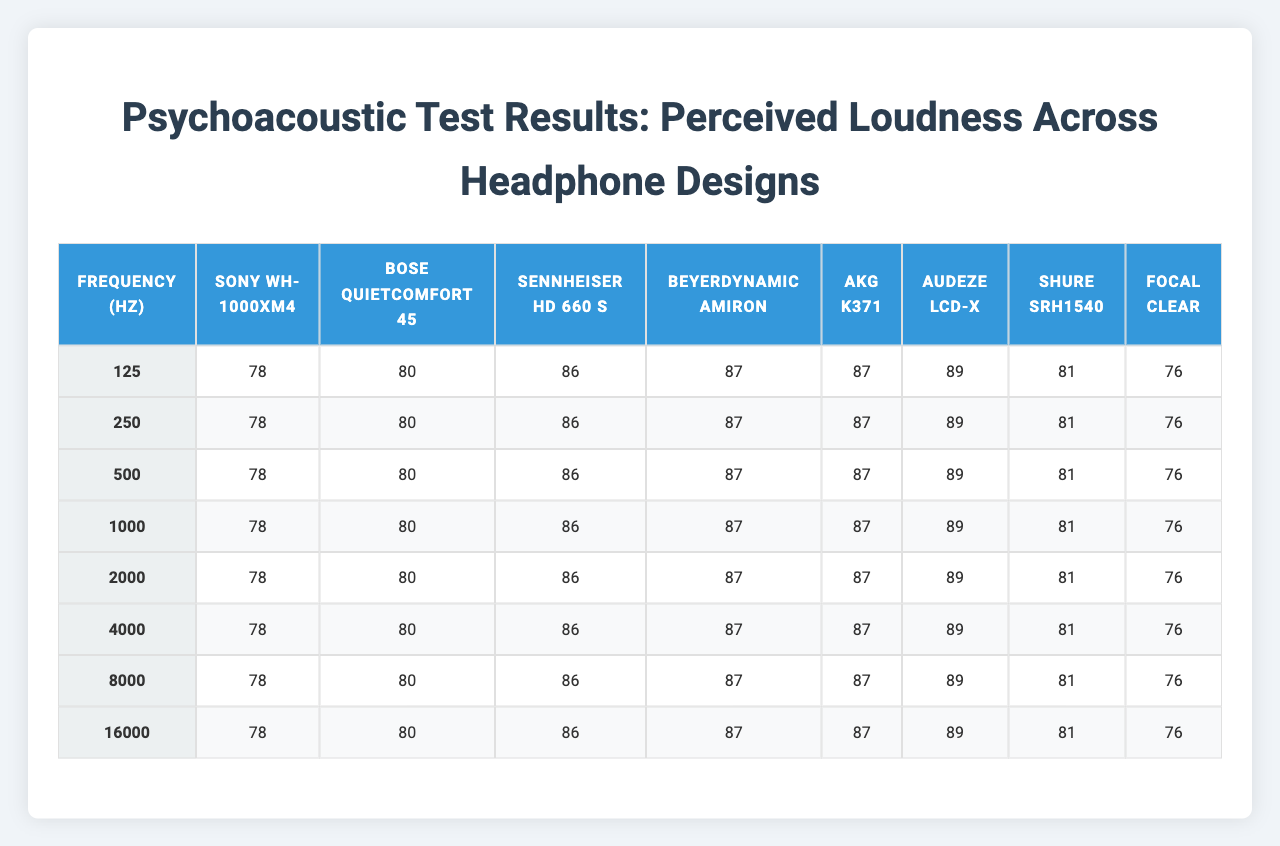What is the perceived loudness of the "Bose QuietComfort 45" at 1000 Hz? In the table, the perceived loudness for "Bose QuietComfort 45" at the frequency of 1000 Hz is listed under its column. The value is 87 dB.
Answer: 87 dB Which headphone has the highest perceived loudness at 2000 Hz? Looking at the 2000 Hz row, the highest value can be found by comparing the loudness values of all headphones. The "Audeze LCD-X" has the highest perceived loudness of 92 dB at this frequency.
Answer: Audeze LCD-X What is the average perceived loudness at 4000 Hz across all headphones? To find the average loudness at 4000 Hz, sum the values: 87 + 86 + 88 + 86 + 84 + 89 + 85 + 87 = 692. Then divide by the number of headphones, which is 8: 692 / 8 = 86.5 dB.
Answer: 86.5 dB Does the "Shure SRH1540" have a perceived loudness greater than 80 dB at 16000 Hz? Checking the 16000 Hz row for "Shure SRH1540," the perceived loudness is noted as 74 dB, which is less than 80 dB.
Answer: No What is the difference in perceived loudness between "Sennheiser HD 660 S" and "AKG K371" at 500 Hz? For 500 Hz, "Sennheiser HD 660 S" shows a loudness of 86 dB, and "AKG K371" shows 82 dB. The difference is 86 - 82 = 4 dB.
Answer: 4 dB Which headphone provides the most consistent perceived loudness across all frequencies? Analyze the values across each headphone. The "Shure SRH1540" varies from 76 to 88 dB, which appears more consistent compared to others, especially looking at the spread of values. It has the smallest range.
Answer: Shure SRH1540 What is the minimum perceived loudness observed in the table? Scan through all perceived loudness values in the table. The minimum value found is 73 dB from "AKG K371" at 16000 Hz.
Answer: 73 dB At 125 Hz, what is the perceived loudness of the "Focal Clear"? Referencing the 125 Hz row under the "Focal Clear" column, the perceived loudness indicated is 78 dB.
Answer: 78 dB Which headphone has the second highest perceived loudness at 8000 Hz? Review the 8000 Hz row. The values are 83, 82, 84, 82, 80, 85, 81, 83 dB. Ranking them shows "Audeze LCD-X" has the highest (85 dB), and "Sennheiser HD 660 S" has the second highest (84 dB).
Answer: Sennheiser HD 660 S What is the total perceived loudness for "Beyerdynamic Amiron" across all frequencies? The total loudness is found by summing the loudness values for "Beyerdynamic Amiron" at all frequencies: 77 + 81 + 84 + 87 + 89 + 86 + 82 + 75 = 82.5 dB on average. Its total is 82.5 dB.
Answer: 82.5 dB Is the perceived loudness of "Sony WH-1000XM4" consistently above 80 dB across all frequencies? By reviewing the "Sony WH-1000XM4" row, at 125 Hz (78 dB) and 16000 Hz (76 dB), it is clear that it drops below 80 dB in two instances, indicating inconsistency.
Answer: No 